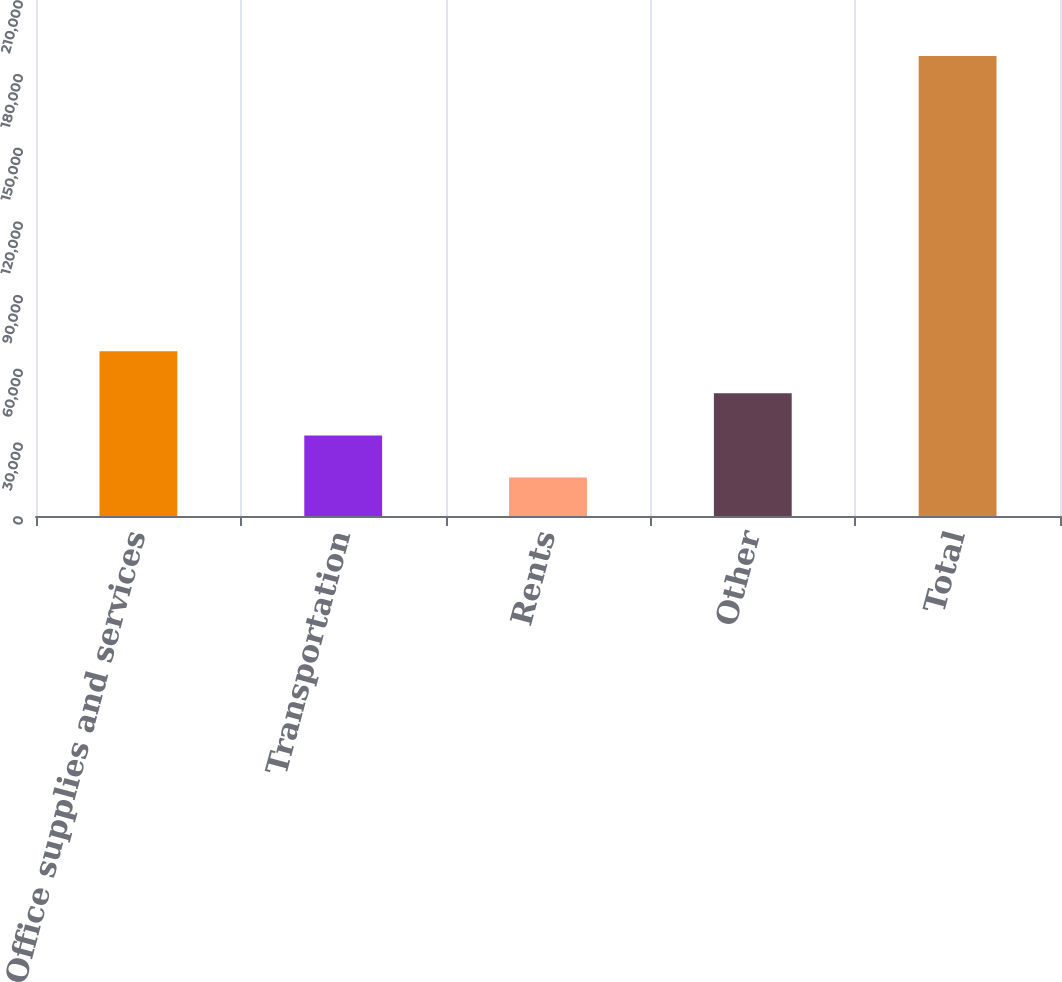Convert chart. <chart><loc_0><loc_0><loc_500><loc_500><bar_chart><fcel>Office supplies and services<fcel>Transportation<fcel>Rents<fcel>Other<fcel>Total<nl><fcel>67097.8<fcel>32778.6<fcel>15619<fcel>49938.2<fcel>187215<nl></chart> 